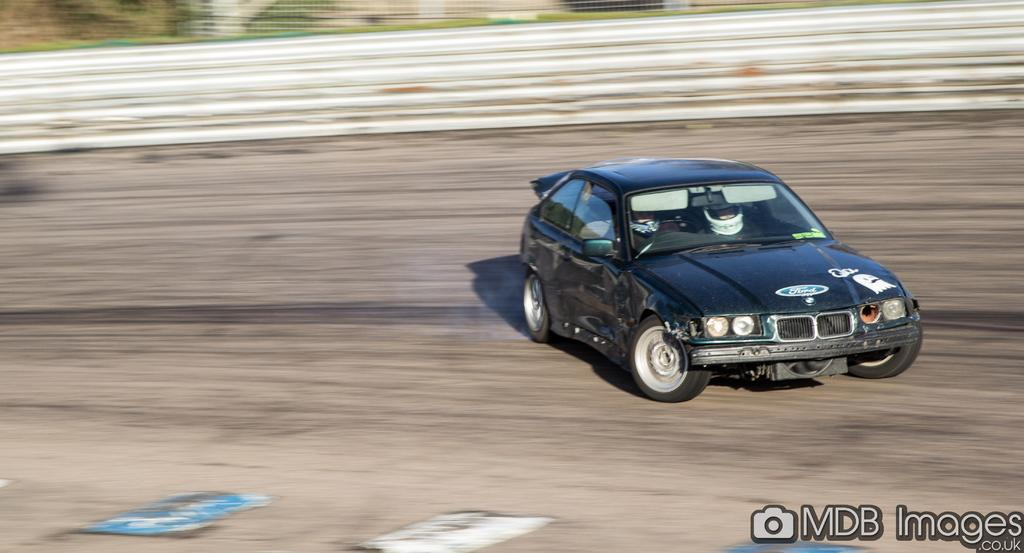What vehicle is located on the right side of the image? There is a car on the right side of the image. Can you describe the background of the image? The background area of the image is blurred. What type of robin can be seen in the image? There is no robin present in the image. What part of the human body is visible in the image? There is no flesh or any part of the human body visible in the image. 